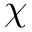Convert formula to latex. <formula><loc_0><loc_0><loc_500><loc_500>\chi</formula> 